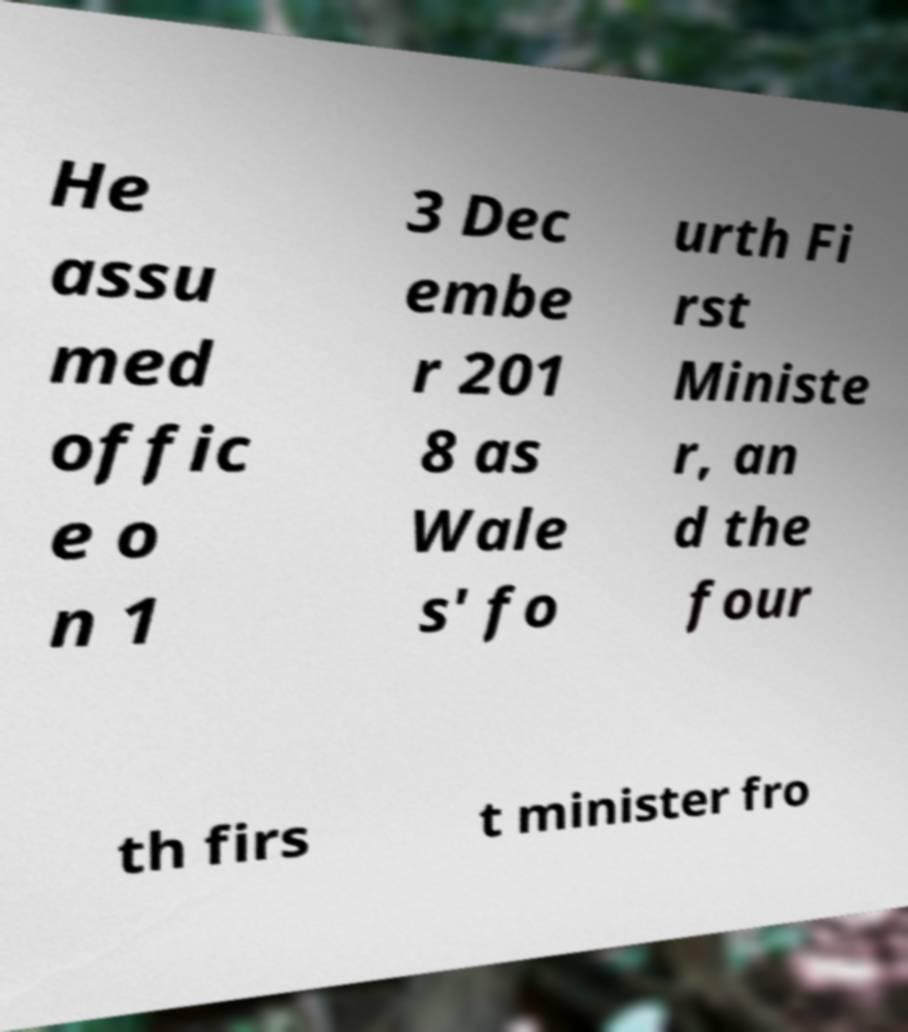Please read and relay the text visible in this image. What does it say? He assu med offic e o n 1 3 Dec embe r 201 8 as Wale s' fo urth Fi rst Ministe r, an d the four th firs t minister fro 